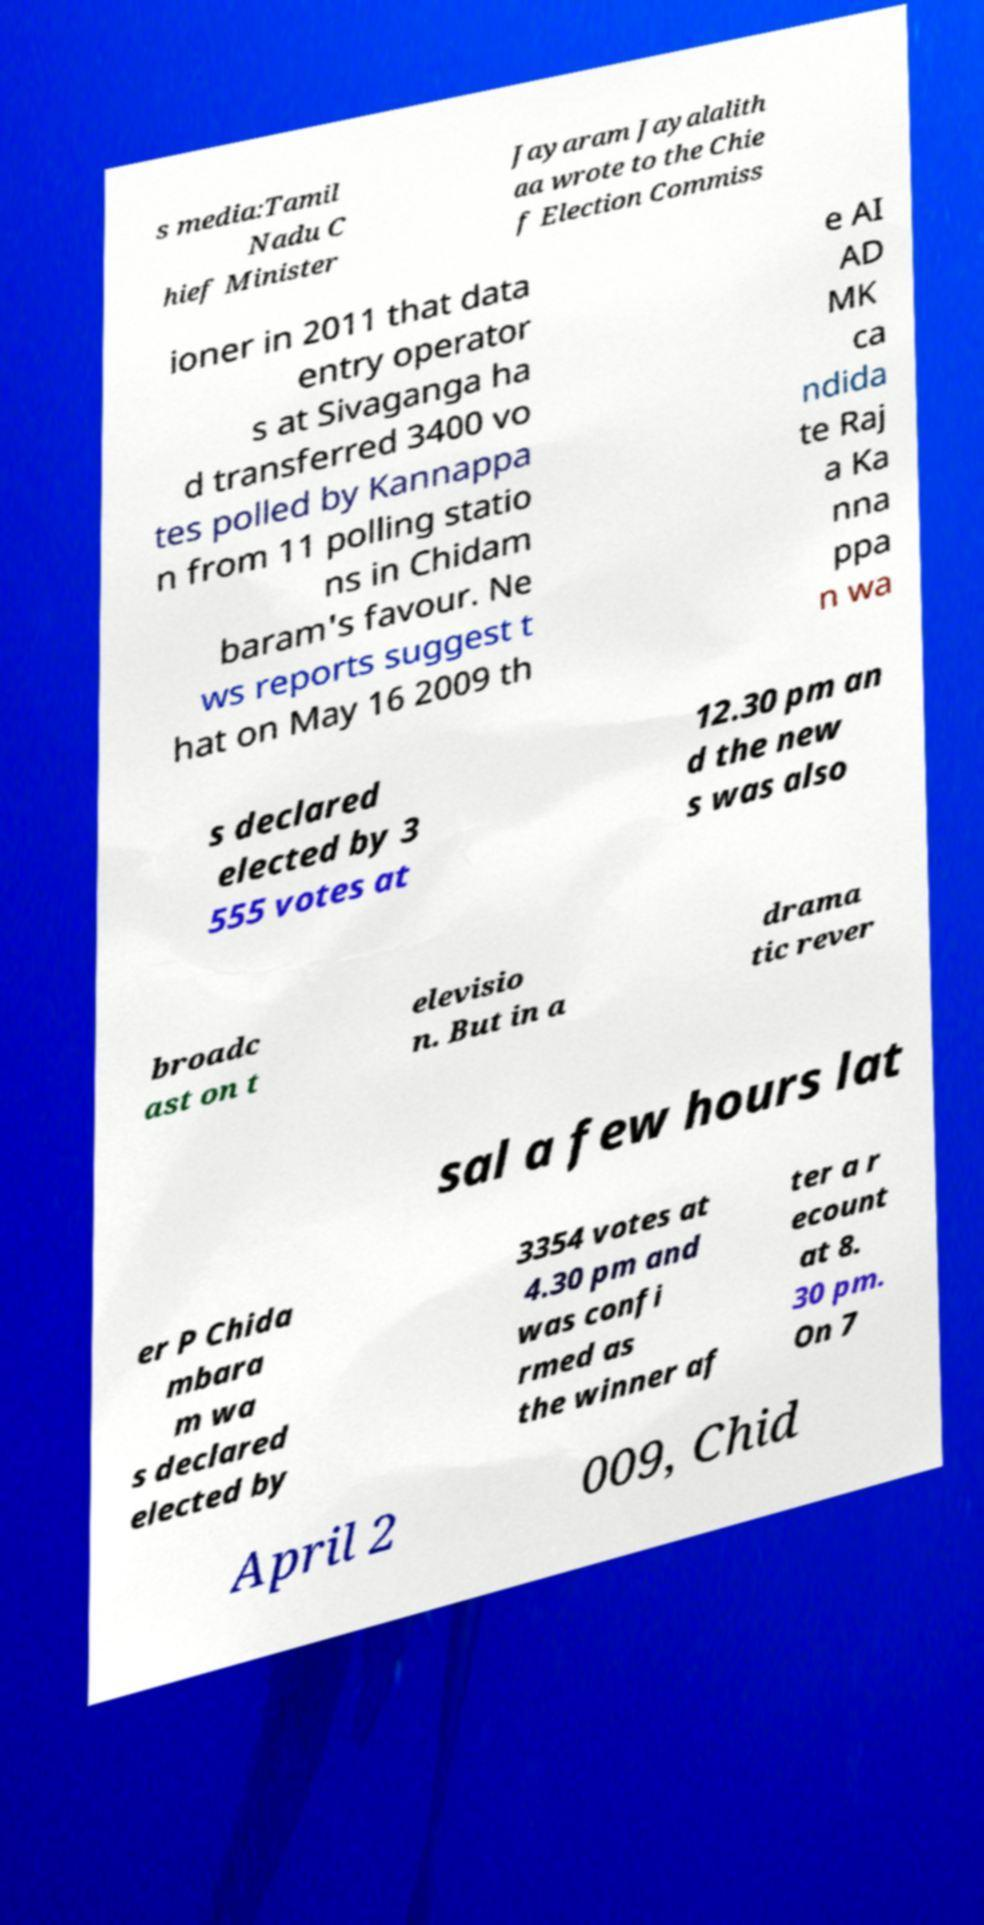Could you assist in decoding the text presented in this image and type it out clearly? s media:Tamil Nadu C hief Minister Jayaram Jayalalith aa wrote to the Chie f Election Commiss ioner in 2011 that data entry operator s at Sivaganga ha d transferred 3400 vo tes polled by Kannappa n from 11 polling statio ns in Chidam baram's favour. Ne ws reports suggest t hat on May 16 2009 th e AI AD MK ca ndida te Raj a Ka nna ppa n wa s declared elected by 3 555 votes at 12.30 pm an d the new s was also broadc ast on t elevisio n. But in a drama tic rever sal a few hours lat er P Chida mbara m wa s declared elected by 3354 votes at 4.30 pm and was confi rmed as the winner af ter a r ecount at 8. 30 pm. On 7 April 2 009, Chid 